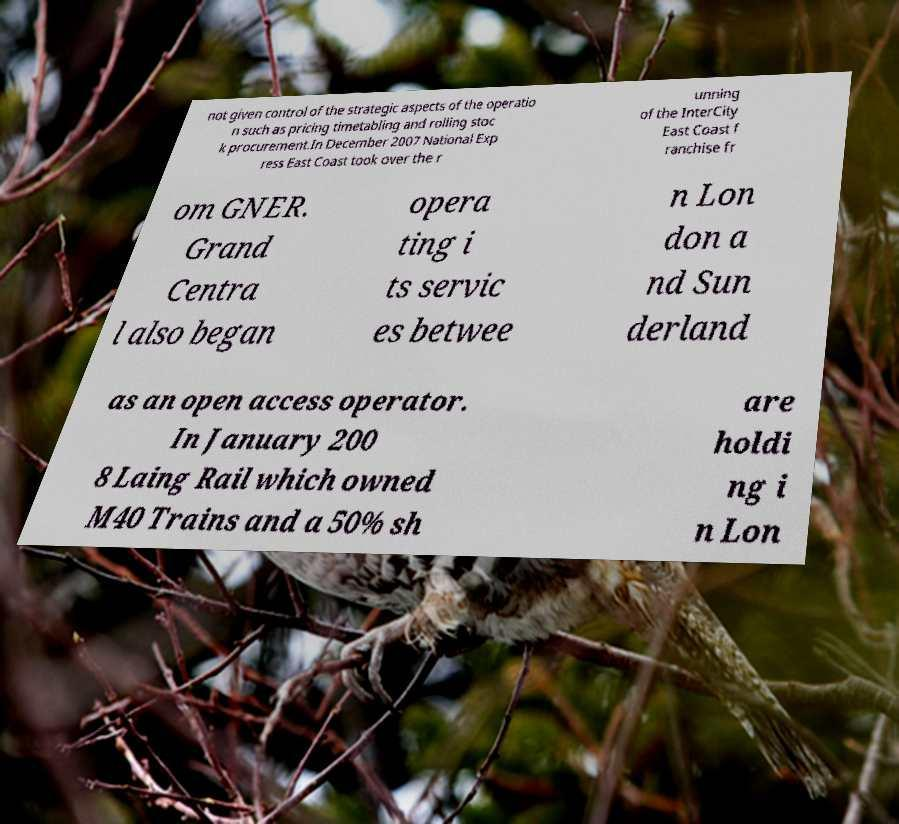Could you extract and type out the text from this image? not given control of the strategic aspects of the operatio n such as pricing timetabling and rolling stoc k procurement.In December 2007 National Exp ress East Coast took over the r unning of the InterCity East Coast f ranchise fr om GNER. Grand Centra l also began opera ting i ts servic es betwee n Lon don a nd Sun derland as an open access operator. In January 200 8 Laing Rail which owned M40 Trains and a 50% sh are holdi ng i n Lon 